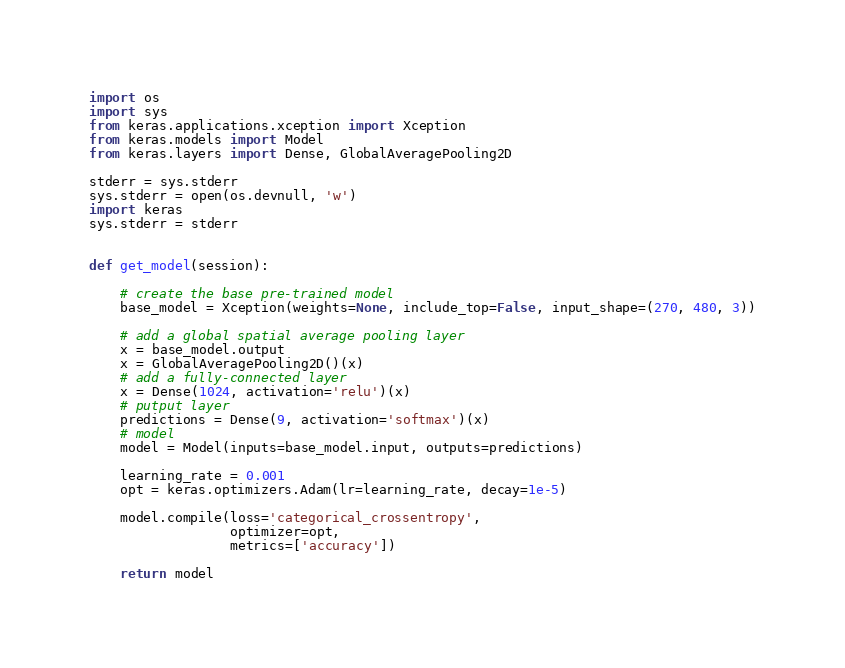<code> <loc_0><loc_0><loc_500><loc_500><_Python_>import os
import sys
from keras.applications.xception import Xception
from keras.models import Model
from keras.layers import Dense, GlobalAveragePooling2D

stderr = sys.stderr
sys.stderr = open(os.devnull, 'w')
import keras
sys.stderr = stderr


def get_model(session):

    # create the base pre-trained model
    base_model = Xception(weights=None, include_top=False, input_shape=(270, 480, 3))

    # add a global spatial average pooling layer
    x = base_model.output
    x = GlobalAveragePooling2D()(x)
    # add a fully-connected layer
    x = Dense(1024, activation='relu')(x)
    # putput layer
    predictions = Dense(9, activation='softmax')(x)
    # model
    model = Model(inputs=base_model.input, outputs=predictions)

    learning_rate = 0.001
    opt = keras.optimizers.Adam(lr=learning_rate, decay=1e-5)

    model.compile(loss='categorical_crossentropy',
                  optimizer=opt,
                  metrics=['accuracy'])

    return model</code> 